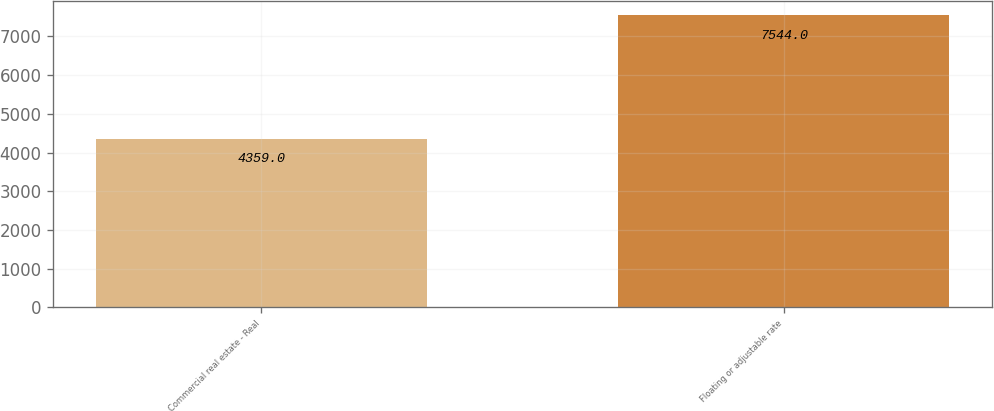<chart> <loc_0><loc_0><loc_500><loc_500><bar_chart><fcel>Commercial real estate - Real<fcel>Floating or adjustable rate<nl><fcel>4359<fcel>7544<nl></chart> 